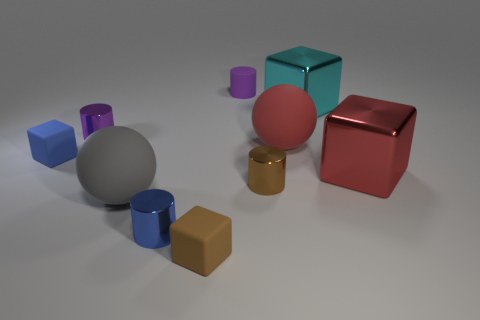Subtract all red blocks. How many purple cylinders are left? 2 Subtract 2 cylinders. How many cylinders are left? 2 Subtract all big red metallic cubes. How many cubes are left? 3 Subtract all yellow blocks. Subtract all purple cylinders. How many blocks are left? 4 Subtract all balls. How many objects are left? 8 Subtract all small blue matte cylinders. Subtract all small shiny cylinders. How many objects are left? 7 Add 4 large red matte spheres. How many large red matte spheres are left? 5 Add 3 big blue metallic spheres. How many big blue metallic spheres exist? 3 Subtract 1 purple cylinders. How many objects are left? 9 